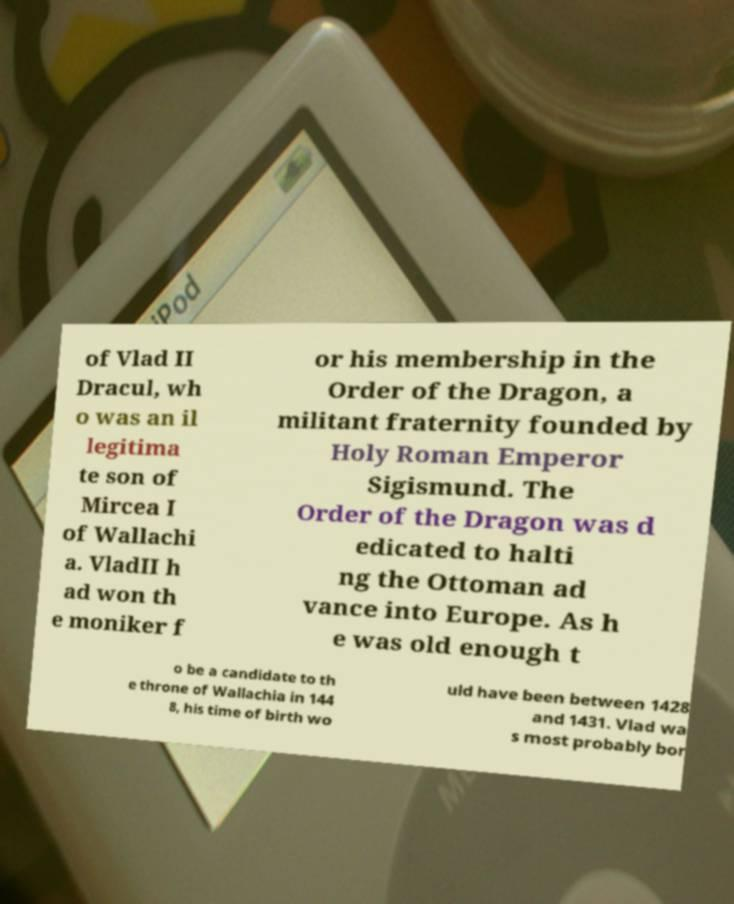Could you assist in decoding the text presented in this image and type it out clearly? of Vlad II Dracul, wh o was an il legitima te son of Mircea I of Wallachi a. VladII h ad won th e moniker f or his membership in the Order of the Dragon, a militant fraternity founded by Holy Roman Emperor Sigismund. The Order of the Dragon was d edicated to halti ng the Ottoman ad vance into Europe. As h e was old enough t o be a candidate to th e throne of Wallachia in 144 8, his time of birth wo uld have been between 1428 and 1431. Vlad wa s most probably bor 